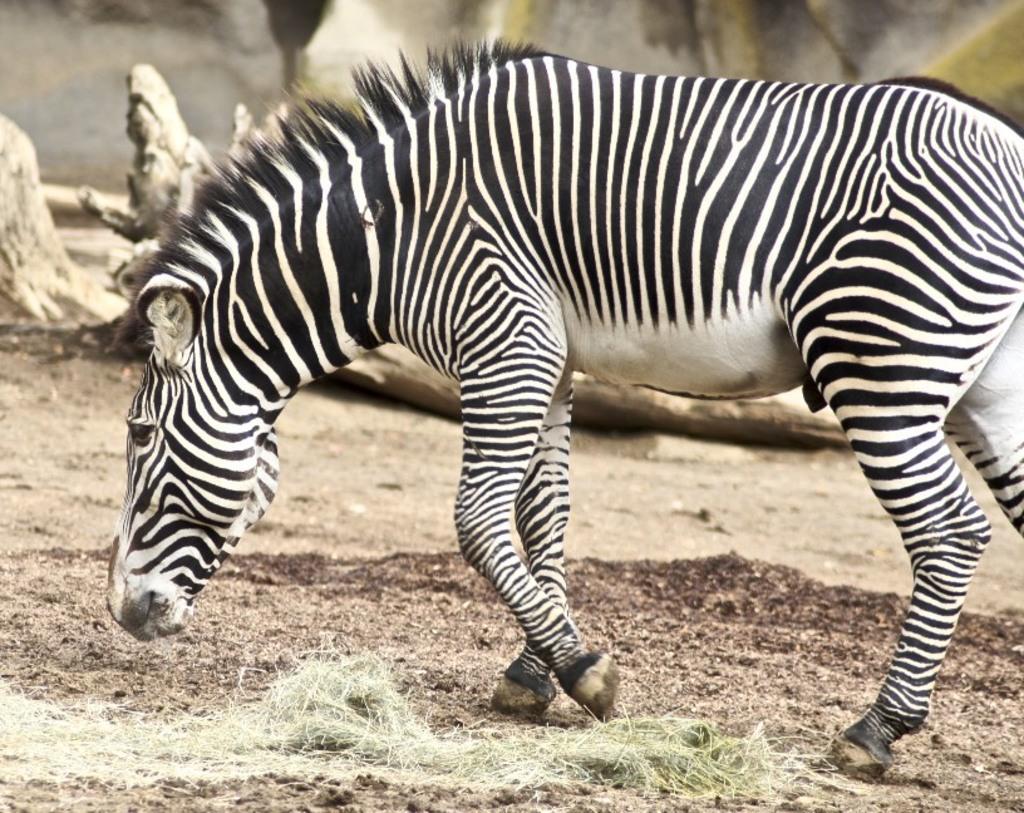Describe this image in one or two sentences. In this image, we can see an animal. We can see the ground and some grass. In the background, we can see some objects. 